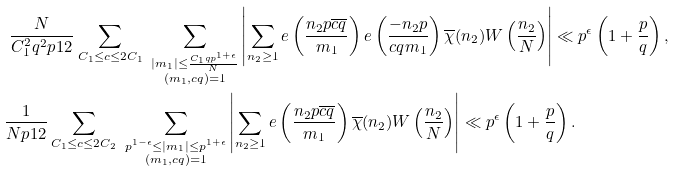<formula> <loc_0><loc_0><loc_500><loc_500>& \ \frac { N } { C _ { 1 } ^ { 2 } q ^ { 2 } p ^ { } { 1 } 2 } \sum _ { \substack { C _ { 1 } \leq c \leq 2 C _ { 1 } } } \ \sum _ { \substack { | m _ { 1 } | \leq \frac { C _ { 1 } q p ^ { 1 + \epsilon } } { N } \\ ( m _ { 1 } , c q ) = 1 } } \left | \sum _ { n _ { 2 } \geq 1 } e \left ( \frac { n _ { 2 } p \overline { c q } } { m _ { 1 } } \right ) e \left ( \frac { - n _ { 2 } p } { c q m _ { 1 } } \right ) \overline { \chi } ( n _ { 2 } ) W \left ( \frac { n _ { 2 } } { N } \right ) \right | \ll p ^ { \epsilon } \left ( 1 + \frac { p } { q } \right ) , \\ & \frac { 1 } { N p ^ { } { 1 } 2 } \sum _ { \substack { C _ { 1 } \leq c \leq 2 C _ { 2 } } } \ \sum _ { \substack { p ^ { 1 - \epsilon } \leq | m _ { 1 } | \leq p ^ { 1 + \epsilon } \\ ( m _ { 1 } , c q ) = 1 } } \left | \sum _ { n _ { 2 } \geq 1 } e \left ( \frac { n _ { 2 } p \overline { c q } } { m _ { 1 } } \right ) \overline { \chi } ( n _ { 2 } ) W \left ( \frac { n _ { 2 } } { N } \right ) \right | \ll p ^ { \epsilon } \left ( 1 + \frac { p } { q } \right ) .</formula> 